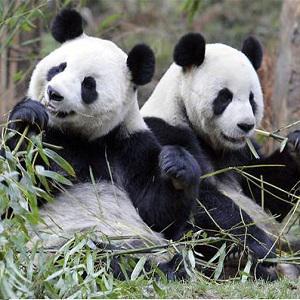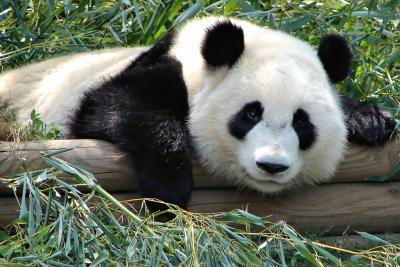The first image is the image on the left, the second image is the image on the right. Evaluate the accuracy of this statement regarding the images: "Two pandas are playing together in each of the images.". Is it true? Answer yes or no. No. The first image is the image on the left, the second image is the image on the right. Assess this claim about the two images: "There is a total of three pandas.". Correct or not? Answer yes or no. Yes. 